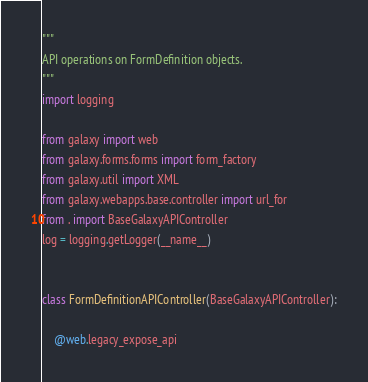<code> <loc_0><loc_0><loc_500><loc_500><_Python_>"""
API operations on FormDefinition objects.
"""
import logging

from galaxy import web
from galaxy.forms.forms import form_factory
from galaxy.util import XML
from galaxy.webapps.base.controller import url_for
from . import BaseGalaxyAPIController
log = logging.getLogger(__name__)


class FormDefinitionAPIController(BaseGalaxyAPIController):

    @web.legacy_expose_api</code> 